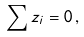<formula> <loc_0><loc_0><loc_500><loc_500>\sum z _ { i } = 0 \, ,</formula> 